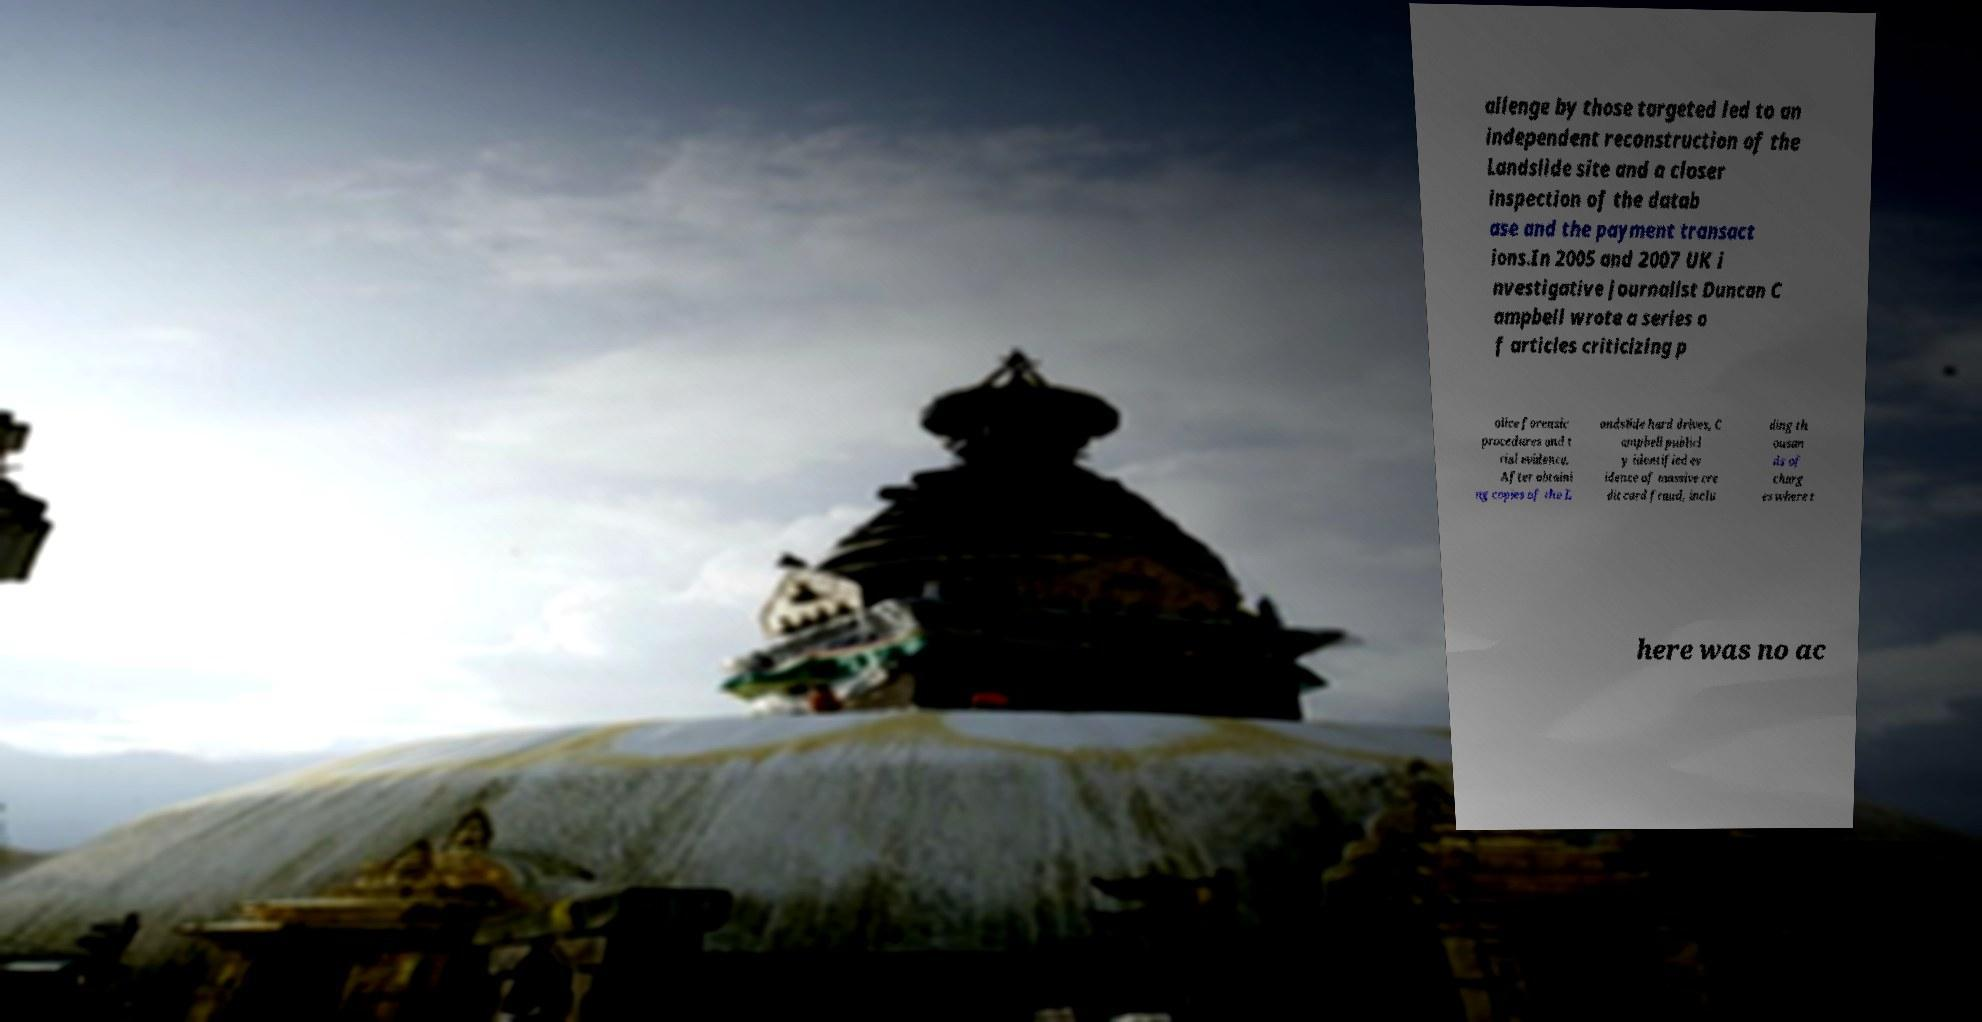What messages or text are displayed in this image? I need them in a readable, typed format. allenge by those targeted led to an independent reconstruction of the Landslide site and a closer inspection of the datab ase and the payment transact ions.In 2005 and 2007 UK i nvestigative journalist Duncan C ampbell wrote a series o f articles criticizing p olice forensic procedures and t rial evidence. After obtaini ng copies of the L andslide hard drives, C ampbell publicl y identified ev idence of massive cre dit card fraud, inclu ding th ousan ds of charg es where t here was no ac 